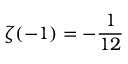<formula> <loc_0><loc_0><loc_500><loc_500>\zeta ( - 1 ) = - { \frac { 1 } { 1 2 } }</formula> 